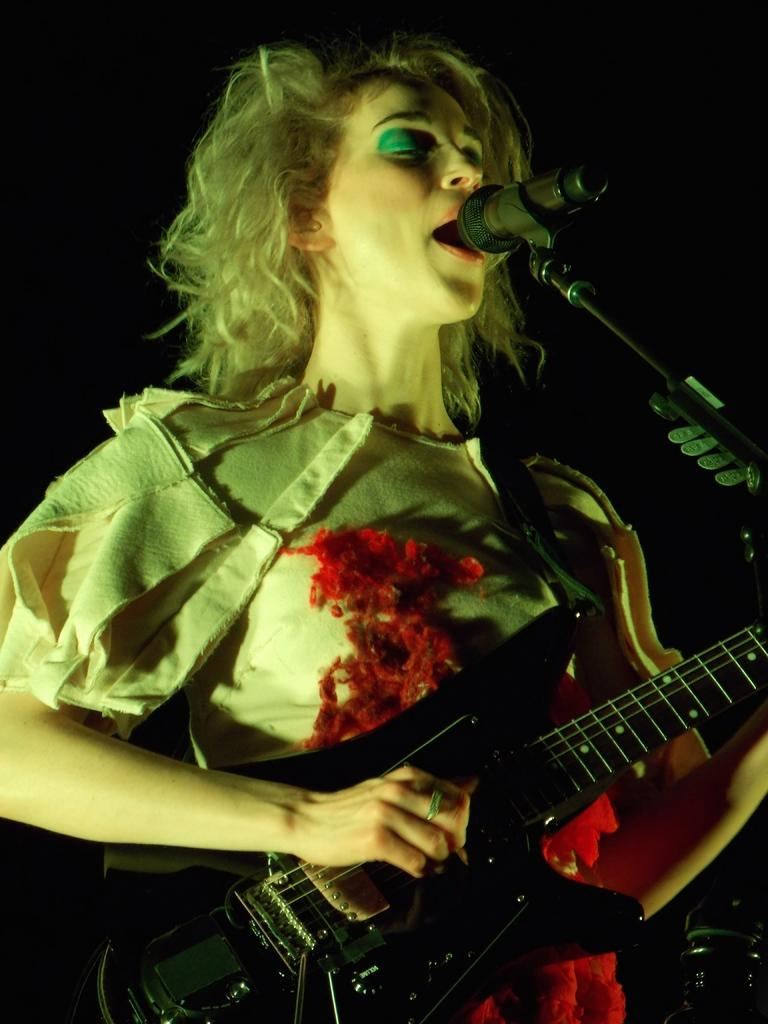Who is the main subject in the image? There is a woman in the image. What is the woman doing in the image? The woman is standing in front of a microphone and playing a guitar. What can be inferred about the setting of the image? The image is taken inside a stage, and the background is dark. What type of food is the woman eating in the image? There is no food present in the image; the woman is playing a guitar and standing in front of a microphone. What month is it in the image? The month cannot be determined from the image, as there is no information about the time of year. 